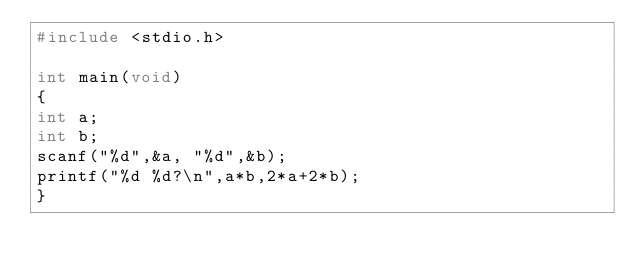<code> <loc_0><loc_0><loc_500><loc_500><_C_>#include <stdio.h>

int main(void)
{
int a;
int b;
scanf("%d",&a, "%d",&b);
printf("%d %d?\n",a*b,2*a+2*b);
}</code> 